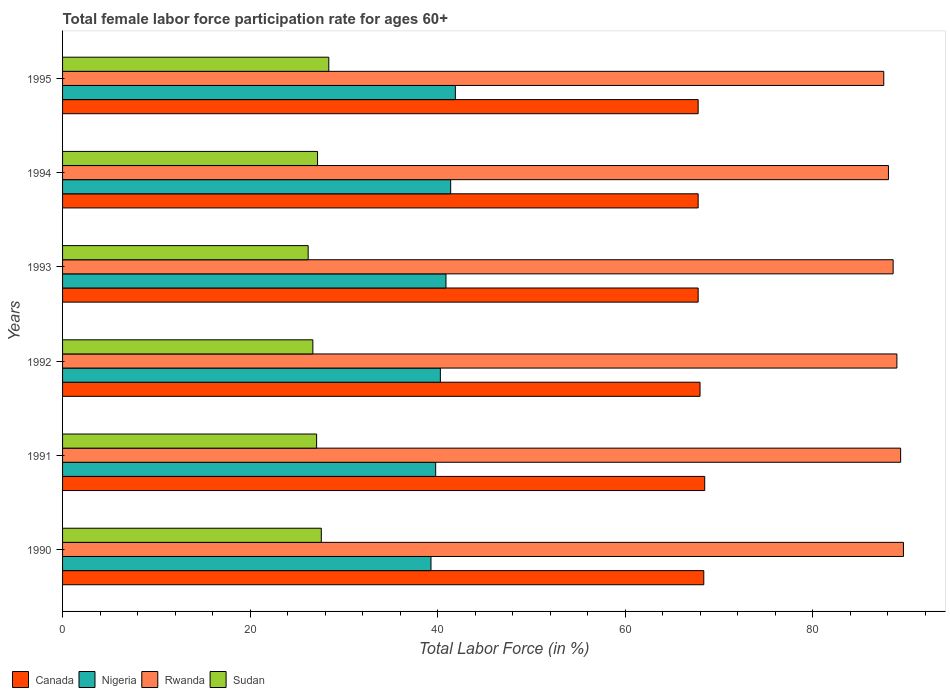How many groups of bars are there?
Offer a terse response. 6. Are the number of bars per tick equal to the number of legend labels?
Your response must be concise. Yes. How many bars are there on the 3rd tick from the top?
Provide a succinct answer. 4. How many bars are there on the 6th tick from the bottom?
Your response must be concise. 4. What is the label of the 2nd group of bars from the top?
Offer a terse response. 1994. In how many cases, is the number of bars for a given year not equal to the number of legend labels?
Give a very brief answer. 0. What is the female labor force participation rate in Canada in 1994?
Provide a short and direct response. 67.8. Across all years, what is the maximum female labor force participation rate in Canada?
Give a very brief answer. 68.5. Across all years, what is the minimum female labor force participation rate in Nigeria?
Offer a very short reply. 39.3. In which year was the female labor force participation rate in Nigeria maximum?
Keep it short and to the point. 1995. What is the total female labor force participation rate in Nigeria in the graph?
Provide a short and direct response. 243.6. What is the difference between the female labor force participation rate in Canada in 1994 and that in 1995?
Give a very brief answer. 0. What is the difference between the female labor force participation rate in Rwanda in 1993 and the female labor force participation rate in Nigeria in 1995?
Ensure brevity in your answer.  46.7. What is the average female labor force participation rate in Canada per year?
Keep it short and to the point. 68.05. In the year 1992, what is the difference between the female labor force participation rate in Canada and female labor force participation rate in Rwanda?
Your answer should be compact. -21. In how many years, is the female labor force participation rate in Nigeria greater than 80 %?
Provide a succinct answer. 0. What is the ratio of the female labor force participation rate in Nigeria in 1991 to that in 1995?
Offer a very short reply. 0.95. Is the female labor force participation rate in Rwanda in 1990 less than that in 1995?
Keep it short and to the point. No. Is the difference between the female labor force participation rate in Canada in 1991 and 1992 greater than the difference between the female labor force participation rate in Rwanda in 1991 and 1992?
Your response must be concise. Yes. What is the difference between the highest and the second highest female labor force participation rate in Nigeria?
Ensure brevity in your answer.  0.5. What is the difference between the highest and the lowest female labor force participation rate in Rwanda?
Ensure brevity in your answer.  2.1. In how many years, is the female labor force participation rate in Canada greater than the average female labor force participation rate in Canada taken over all years?
Keep it short and to the point. 2. Is it the case that in every year, the sum of the female labor force participation rate in Canada and female labor force participation rate in Rwanda is greater than the sum of female labor force participation rate in Sudan and female labor force participation rate in Nigeria?
Make the answer very short. No. What does the 3rd bar from the top in 1995 represents?
Keep it short and to the point. Nigeria. What does the 2nd bar from the bottom in 1991 represents?
Make the answer very short. Nigeria. Is it the case that in every year, the sum of the female labor force participation rate in Nigeria and female labor force participation rate in Canada is greater than the female labor force participation rate in Sudan?
Provide a succinct answer. Yes. Are all the bars in the graph horizontal?
Your response must be concise. Yes. What is the difference between two consecutive major ticks on the X-axis?
Offer a terse response. 20. Are the values on the major ticks of X-axis written in scientific E-notation?
Keep it short and to the point. No. Does the graph contain any zero values?
Your answer should be compact. No. Where does the legend appear in the graph?
Give a very brief answer. Bottom left. What is the title of the graph?
Ensure brevity in your answer.  Total female labor force participation rate for ages 60+. What is the label or title of the X-axis?
Give a very brief answer. Total Labor Force (in %). What is the label or title of the Y-axis?
Keep it short and to the point. Years. What is the Total Labor Force (in %) in Canada in 1990?
Your answer should be very brief. 68.4. What is the Total Labor Force (in %) in Nigeria in 1990?
Your response must be concise. 39.3. What is the Total Labor Force (in %) of Rwanda in 1990?
Your answer should be very brief. 89.7. What is the Total Labor Force (in %) in Sudan in 1990?
Your answer should be compact. 27.6. What is the Total Labor Force (in %) of Canada in 1991?
Offer a very short reply. 68.5. What is the Total Labor Force (in %) of Nigeria in 1991?
Your answer should be very brief. 39.8. What is the Total Labor Force (in %) of Rwanda in 1991?
Provide a succinct answer. 89.4. What is the Total Labor Force (in %) of Sudan in 1991?
Offer a very short reply. 27.1. What is the Total Labor Force (in %) of Canada in 1992?
Offer a terse response. 68. What is the Total Labor Force (in %) in Nigeria in 1992?
Provide a short and direct response. 40.3. What is the Total Labor Force (in %) of Rwanda in 1992?
Provide a succinct answer. 89. What is the Total Labor Force (in %) of Sudan in 1992?
Keep it short and to the point. 26.7. What is the Total Labor Force (in %) of Canada in 1993?
Give a very brief answer. 67.8. What is the Total Labor Force (in %) in Nigeria in 1993?
Make the answer very short. 40.9. What is the Total Labor Force (in %) in Rwanda in 1993?
Your response must be concise. 88.6. What is the Total Labor Force (in %) of Sudan in 1993?
Your response must be concise. 26.2. What is the Total Labor Force (in %) of Canada in 1994?
Your answer should be very brief. 67.8. What is the Total Labor Force (in %) of Nigeria in 1994?
Offer a terse response. 41.4. What is the Total Labor Force (in %) of Rwanda in 1994?
Provide a short and direct response. 88.1. What is the Total Labor Force (in %) in Sudan in 1994?
Give a very brief answer. 27.2. What is the Total Labor Force (in %) in Canada in 1995?
Provide a succinct answer. 67.8. What is the Total Labor Force (in %) of Nigeria in 1995?
Keep it short and to the point. 41.9. What is the Total Labor Force (in %) in Rwanda in 1995?
Ensure brevity in your answer.  87.6. What is the Total Labor Force (in %) of Sudan in 1995?
Ensure brevity in your answer.  28.4. Across all years, what is the maximum Total Labor Force (in %) of Canada?
Make the answer very short. 68.5. Across all years, what is the maximum Total Labor Force (in %) of Nigeria?
Your answer should be compact. 41.9. Across all years, what is the maximum Total Labor Force (in %) of Rwanda?
Make the answer very short. 89.7. Across all years, what is the maximum Total Labor Force (in %) in Sudan?
Your answer should be compact. 28.4. Across all years, what is the minimum Total Labor Force (in %) of Canada?
Offer a terse response. 67.8. Across all years, what is the minimum Total Labor Force (in %) in Nigeria?
Your response must be concise. 39.3. Across all years, what is the minimum Total Labor Force (in %) in Rwanda?
Your response must be concise. 87.6. Across all years, what is the minimum Total Labor Force (in %) in Sudan?
Offer a terse response. 26.2. What is the total Total Labor Force (in %) in Canada in the graph?
Offer a very short reply. 408.3. What is the total Total Labor Force (in %) of Nigeria in the graph?
Offer a very short reply. 243.6. What is the total Total Labor Force (in %) in Rwanda in the graph?
Provide a succinct answer. 532.4. What is the total Total Labor Force (in %) of Sudan in the graph?
Make the answer very short. 163.2. What is the difference between the Total Labor Force (in %) in Canada in 1990 and that in 1991?
Provide a short and direct response. -0.1. What is the difference between the Total Labor Force (in %) of Nigeria in 1990 and that in 1991?
Your answer should be compact. -0.5. What is the difference between the Total Labor Force (in %) in Rwanda in 1990 and that in 1991?
Give a very brief answer. 0.3. What is the difference between the Total Labor Force (in %) in Nigeria in 1990 and that in 1992?
Your answer should be compact. -1. What is the difference between the Total Labor Force (in %) in Rwanda in 1990 and that in 1992?
Keep it short and to the point. 0.7. What is the difference between the Total Labor Force (in %) of Canada in 1990 and that in 1993?
Offer a terse response. 0.6. What is the difference between the Total Labor Force (in %) in Sudan in 1990 and that in 1993?
Make the answer very short. 1.4. What is the difference between the Total Labor Force (in %) in Canada in 1990 and that in 1994?
Provide a short and direct response. 0.6. What is the difference between the Total Labor Force (in %) of Nigeria in 1990 and that in 1994?
Offer a very short reply. -2.1. What is the difference between the Total Labor Force (in %) in Rwanda in 1990 and that in 1994?
Ensure brevity in your answer.  1.6. What is the difference between the Total Labor Force (in %) of Sudan in 1990 and that in 1994?
Offer a very short reply. 0.4. What is the difference between the Total Labor Force (in %) of Canada in 1990 and that in 1995?
Keep it short and to the point. 0.6. What is the difference between the Total Labor Force (in %) in Nigeria in 1990 and that in 1995?
Make the answer very short. -2.6. What is the difference between the Total Labor Force (in %) of Rwanda in 1990 and that in 1995?
Ensure brevity in your answer.  2.1. What is the difference between the Total Labor Force (in %) of Sudan in 1990 and that in 1995?
Give a very brief answer. -0.8. What is the difference between the Total Labor Force (in %) in Canada in 1991 and that in 1992?
Give a very brief answer. 0.5. What is the difference between the Total Labor Force (in %) of Rwanda in 1991 and that in 1992?
Your answer should be very brief. 0.4. What is the difference between the Total Labor Force (in %) of Sudan in 1991 and that in 1992?
Give a very brief answer. 0.4. What is the difference between the Total Labor Force (in %) of Canada in 1991 and that in 1993?
Offer a terse response. 0.7. What is the difference between the Total Labor Force (in %) of Nigeria in 1991 and that in 1993?
Offer a terse response. -1.1. What is the difference between the Total Labor Force (in %) in Sudan in 1991 and that in 1993?
Your answer should be compact. 0.9. What is the difference between the Total Labor Force (in %) of Canada in 1991 and that in 1994?
Ensure brevity in your answer.  0.7. What is the difference between the Total Labor Force (in %) in Rwanda in 1991 and that in 1994?
Make the answer very short. 1.3. What is the difference between the Total Labor Force (in %) in Sudan in 1991 and that in 1994?
Provide a short and direct response. -0.1. What is the difference between the Total Labor Force (in %) of Canada in 1991 and that in 1995?
Your answer should be compact. 0.7. What is the difference between the Total Labor Force (in %) in Sudan in 1991 and that in 1995?
Make the answer very short. -1.3. What is the difference between the Total Labor Force (in %) of Nigeria in 1992 and that in 1993?
Keep it short and to the point. -0.6. What is the difference between the Total Labor Force (in %) of Rwanda in 1992 and that in 1993?
Keep it short and to the point. 0.4. What is the difference between the Total Labor Force (in %) in Sudan in 1992 and that in 1993?
Keep it short and to the point. 0.5. What is the difference between the Total Labor Force (in %) in Canada in 1992 and that in 1994?
Ensure brevity in your answer.  0.2. What is the difference between the Total Labor Force (in %) of Nigeria in 1992 and that in 1994?
Offer a very short reply. -1.1. What is the difference between the Total Labor Force (in %) of Rwanda in 1992 and that in 1994?
Offer a very short reply. 0.9. What is the difference between the Total Labor Force (in %) in Sudan in 1992 and that in 1994?
Make the answer very short. -0.5. What is the difference between the Total Labor Force (in %) of Nigeria in 1992 and that in 1995?
Your answer should be compact. -1.6. What is the difference between the Total Labor Force (in %) in Rwanda in 1992 and that in 1995?
Give a very brief answer. 1.4. What is the difference between the Total Labor Force (in %) in Canada in 1993 and that in 1994?
Your response must be concise. 0. What is the difference between the Total Labor Force (in %) in Nigeria in 1993 and that in 1994?
Provide a succinct answer. -0.5. What is the difference between the Total Labor Force (in %) of Rwanda in 1993 and that in 1994?
Ensure brevity in your answer.  0.5. What is the difference between the Total Labor Force (in %) of Canada in 1993 and that in 1995?
Ensure brevity in your answer.  0. What is the difference between the Total Labor Force (in %) of Nigeria in 1993 and that in 1995?
Your answer should be very brief. -1. What is the difference between the Total Labor Force (in %) in Rwanda in 1993 and that in 1995?
Give a very brief answer. 1. What is the difference between the Total Labor Force (in %) in Sudan in 1993 and that in 1995?
Your answer should be compact. -2.2. What is the difference between the Total Labor Force (in %) in Sudan in 1994 and that in 1995?
Your answer should be compact. -1.2. What is the difference between the Total Labor Force (in %) in Canada in 1990 and the Total Labor Force (in %) in Nigeria in 1991?
Offer a very short reply. 28.6. What is the difference between the Total Labor Force (in %) of Canada in 1990 and the Total Labor Force (in %) of Sudan in 1991?
Your answer should be compact. 41.3. What is the difference between the Total Labor Force (in %) of Nigeria in 1990 and the Total Labor Force (in %) of Rwanda in 1991?
Offer a terse response. -50.1. What is the difference between the Total Labor Force (in %) in Nigeria in 1990 and the Total Labor Force (in %) in Sudan in 1991?
Offer a terse response. 12.2. What is the difference between the Total Labor Force (in %) in Rwanda in 1990 and the Total Labor Force (in %) in Sudan in 1991?
Offer a terse response. 62.6. What is the difference between the Total Labor Force (in %) of Canada in 1990 and the Total Labor Force (in %) of Nigeria in 1992?
Provide a short and direct response. 28.1. What is the difference between the Total Labor Force (in %) of Canada in 1990 and the Total Labor Force (in %) of Rwanda in 1992?
Offer a terse response. -20.6. What is the difference between the Total Labor Force (in %) of Canada in 1990 and the Total Labor Force (in %) of Sudan in 1992?
Offer a terse response. 41.7. What is the difference between the Total Labor Force (in %) in Nigeria in 1990 and the Total Labor Force (in %) in Rwanda in 1992?
Provide a succinct answer. -49.7. What is the difference between the Total Labor Force (in %) in Canada in 1990 and the Total Labor Force (in %) in Nigeria in 1993?
Provide a succinct answer. 27.5. What is the difference between the Total Labor Force (in %) in Canada in 1990 and the Total Labor Force (in %) in Rwanda in 1993?
Offer a terse response. -20.2. What is the difference between the Total Labor Force (in %) in Canada in 1990 and the Total Labor Force (in %) in Sudan in 1993?
Make the answer very short. 42.2. What is the difference between the Total Labor Force (in %) of Nigeria in 1990 and the Total Labor Force (in %) of Rwanda in 1993?
Provide a succinct answer. -49.3. What is the difference between the Total Labor Force (in %) in Nigeria in 1990 and the Total Labor Force (in %) in Sudan in 1993?
Make the answer very short. 13.1. What is the difference between the Total Labor Force (in %) of Rwanda in 1990 and the Total Labor Force (in %) of Sudan in 1993?
Provide a short and direct response. 63.5. What is the difference between the Total Labor Force (in %) in Canada in 1990 and the Total Labor Force (in %) in Nigeria in 1994?
Provide a succinct answer. 27. What is the difference between the Total Labor Force (in %) of Canada in 1990 and the Total Labor Force (in %) of Rwanda in 1994?
Offer a terse response. -19.7. What is the difference between the Total Labor Force (in %) in Canada in 1990 and the Total Labor Force (in %) in Sudan in 1994?
Offer a terse response. 41.2. What is the difference between the Total Labor Force (in %) in Nigeria in 1990 and the Total Labor Force (in %) in Rwanda in 1994?
Make the answer very short. -48.8. What is the difference between the Total Labor Force (in %) of Rwanda in 1990 and the Total Labor Force (in %) of Sudan in 1994?
Provide a succinct answer. 62.5. What is the difference between the Total Labor Force (in %) in Canada in 1990 and the Total Labor Force (in %) in Rwanda in 1995?
Offer a very short reply. -19.2. What is the difference between the Total Labor Force (in %) in Nigeria in 1990 and the Total Labor Force (in %) in Rwanda in 1995?
Your answer should be very brief. -48.3. What is the difference between the Total Labor Force (in %) of Rwanda in 1990 and the Total Labor Force (in %) of Sudan in 1995?
Provide a short and direct response. 61.3. What is the difference between the Total Labor Force (in %) in Canada in 1991 and the Total Labor Force (in %) in Nigeria in 1992?
Ensure brevity in your answer.  28.2. What is the difference between the Total Labor Force (in %) in Canada in 1991 and the Total Labor Force (in %) in Rwanda in 1992?
Give a very brief answer. -20.5. What is the difference between the Total Labor Force (in %) of Canada in 1991 and the Total Labor Force (in %) of Sudan in 1992?
Your response must be concise. 41.8. What is the difference between the Total Labor Force (in %) in Nigeria in 1991 and the Total Labor Force (in %) in Rwanda in 1992?
Your answer should be compact. -49.2. What is the difference between the Total Labor Force (in %) of Nigeria in 1991 and the Total Labor Force (in %) of Sudan in 1992?
Keep it short and to the point. 13.1. What is the difference between the Total Labor Force (in %) in Rwanda in 1991 and the Total Labor Force (in %) in Sudan in 1992?
Your response must be concise. 62.7. What is the difference between the Total Labor Force (in %) in Canada in 1991 and the Total Labor Force (in %) in Nigeria in 1993?
Your answer should be compact. 27.6. What is the difference between the Total Labor Force (in %) in Canada in 1991 and the Total Labor Force (in %) in Rwanda in 1993?
Make the answer very short. -20.1. What is the difference between the Total Labor Force (in %) of Canada in 1991 and the Total Labor Force (in %) of Sudan in 1993?
Offer a terse response. 42.3. What is the difference between the Total Labor Force (in %) of Nigeria in 1991 and the Total Labor Force (in %) of Rwanda in 1993?
Your answer should be compact. -48.8. What is the difference between the Total Labor Force (in %) of Nigeria in 1991 and the Total Labor Force (in %) of Sudan in 1993?
Your answer should be very brief. 13.6. What is the difference between the Total Labor Force (in %) in Rwanda in 1991 and the Total Labor Force (in %) in Sudan in 1993?
Ensure brevity in your answer.  63.2. What is the difference between the Total Labor Force (in %) in Canada in 1991 and the Total Labor Force (in %) in Nigeria in 1994?
Make the answer very short. 27.1. What is the difference between the Total Labor Force (in %) in Canada in 1991 and the Total Labor Force (in %) in Rwanda in 1994?
Your answer should be very brief. -19.6. What is the difference between the Total Labor Force (in %) of Canada in 1991 and the Total Labor Force (in %) of Sudan in 1994?
Your response must be concise. 41.3. What is the difference between the Total Labor Force (in %) in Nigeria in 1991 and the Total Labor Force (in %) in Rwanda in 1994?
Your answer should be compact. -48.3. What is the difference between the Total Labor Force (in %) in Rwanda in 1991 and the Total Labor Force (in %) in Sudan in 1994?
Provide a short and direct response. 62.2. What is the difference between the Total Labor Force (in %) of Canada in 1991 and the Total Labor Force (in %) of Nigeria in 1995?
Offer a terse response. 26.6. What is the difference between the Total Labor Force (in %) of Canada in 1991 and the Total Labor Force (in %) of Rwanda in 1995?
Give a very brief answer. -19.1. What is the difference between the Total Labor Force (in %) in Canada in 1991 and the Total Labor Force (in %) in Sudan in 1995?
Provide a succinct answer. 40.1. What is the difference between the Total Labor Force (in %) of Nigeria in 1991 and the Total Labor Force (in %) of Rwanda in 1995?
Offer a very short reply. -47.8. What is the difference between the Total Labor Force (in %) in Nigeria in 1991 and the Total Labor Force (in %) in Sudan in 1995?
Your answer should be very brief. 11.4. What is the difference between the Total Labor Force (in %) in Rwanda in 1991 and the Total Labor Force (in %) in Sudan in 1995?
Provide a succinct answer. 61. What is the difference between the Total Labor Force (in %) of Canada in 1992 and the Total Labor Force (in %) of Nigeria in 1993?
Your answer should be very brief. 27.1. What is the difference between the Total Labor Force (in %) of Canada in 1992 and the Total Labor Force (in %) of Rwanda in 1993?
Offer a very short reply. -20.6. What is the difference between the Total Labor Force (in %) of Canada in 1992 and the Total Labor Force (in %) of Sudan in 1993?
Ensure brevity in your answer.  41.8. What is the difference between the Total Labor Force (in %) in Nigeria in 1992 and the Total Labor Force (in %) in Rwanda in 1993?
Offer a very short reply. -48.3. What is the difference between the Total Labor Force (in %) in Nigeria in 1992 and the Total Labor Force (in %) in Sudan in 1993?
Give a very brief answer. 14.1. What is the difference between the Total Labor Force (in %) of Rwanda in 1992 and the Total Labor Force (in %) of Sudan in 1993?
Provide a short and direct response. 62.8. What is the difference between the Total Labor Force (in %) in Canada in 1992 and the Total Labor Force (in %) in Nigeria in 1994?
Keep it short and to the point. 26.6. What is the difference between the Total Labor Force (in %) in Canada in 1992 and the Total Labor Force (in %) in Rwanda in 1994?
Provide a short and direct response. -20.1. What is the difference between the Total Labor Force (in %) of Canada in 1992 and the Total Labor Force (in %) of Sudan in 1994?
Your answer should be very brief. 40.8. What is the difference between the Total Labor Force (in %) of Nigeria in 1992 and the Total Labor Force (in %) of Rwanda in 1994?
Offer a very short reply. -47.8. What is the difference between the Total Labor Force (in %) in Rwanda in 1992 and the Total Labor Force (in %) in Sudan in 1994?
Your answer should be very brief. 61.8. What is the difference between the Total Labor Force (in %) in Canada in 1992 and the Total Labor Force (in %) in Nigeria in 1995?
Offer a terse response. 26.1. What is the difference between the Total Labor Force (in %) in Canada in 1992 and the Total Labor Force (in %) in Rwanda in 1995?
Provide a short and direct response. -19.6. What is the difference between the Total Labor Force (in %) of Canada in 1992 and the Total Labor Force (in %) of Sudan in 1995?
Make the answer very short. 39.6. What is the difference between the Total Labor Force (in %) of Nigeria in 1992 and the Total Labor Force (in %) of Rwanda in 1995?
Offer a very short reply. -47.3. What is the difference between the Total Labor Force (in %) of Nigeria in 1992 and the Total Labor Force (in %) of Sudan in 1995?
Provide a short and direct response. 11.9. What is the difference between the Total Labor Force (in %) of Rwanda in 1992 and the Total Labor Force (in %) of Sudan in 1995?
Your answer should be compact. 60.6. What is the difference between the Total Labor Force (in %) of Canada in 1993 and the Total Labor Force (in %) of Nigeria in 1994?
Give a very brief answer. 26.4. What is the difference between the Total Labor Force (in %) of Canada in 1993 and the Total Labor Force (in %) of Rwanda in 1994?
Ensure brevity in your answer.  -20.3. What is the difference between the Total Labor Force (in %) of Canada in 1993 and the Total Labor Force (in %) of Sudan in 1994?
Your answer should be compact. 40.6. What is the difference between the Total Labor Force (in %) in Nigeria in 1993 and the Total Labor Force (in %) in Rwanda in 1994?
Offer a very short reply. -47.2. What is the difference between the Total Labor Force (in %) in Nigeria in 1993 and the Total Labor Force (in %) in Sudan in 1994?
Your response must be concise. 13.7. What is the difference between the Total Labor Force (in %) in Rwanda in 1993 and the Total Labor Force (in %) in Sudan in 1994?
Give a very brief answer. 61.4. What is the difference between the Total Labor Force (in %) in Canada in 1993 and the Total Labor Force (in %) in Nigeria in 1995?
Give a very brief answer. 25.9. What is the difference between the Total Labor Force (in %) in Canada in 1993 and the Total Labor Force (in %) in Rwanda in 1995?
Ensure brevity in your answer.  -19.8. What is the difference between the Total Labor Force (in %) in Canada in 1993 and the Total Labor Force (in %) in Sudan in 1995?
Give a very brief answer. 39.4. What is the difference between the Total Labor Force (in %) of Nigeria in 1993 and the Total Labor Force (in %) of Rwanda in 1995?
Make the answer very short. -46.7. What is the difference between the Total Labor Force (in %) of Nigeria in 1993 and the Total Labor Force (in %) of Sudan in 1995?
Make the answer very short. 12.5. What is the difference between the Total Labor Force (in %) in Rwanda in 1993 and the Total Labor Force (in %) in Sudan in 1995?
Offer a terse response. 60.2. What is the difference between the Total Labor Force (in %) of Canada in 1994 and the Total Labor Force (in %) of Nigeria in 1995?
Make the answer very short. 25.9. What is the difference between the Total Labor Force (in %) of Canada in 1994 and the Total Labor Force (in %) of Rwanda in 1995?
Offer a terse response. -19.8. What is the difference between the Total Labor Force (in %) in Canada in 1994 and the Total Labor Force (in %) in Sudan in 1995?
Give a very brief answer. 39.4. What is the difference between the Total Labor Force (in %) in Nigeria in 1994 and the Total Labor Force (in %) in Rwanda in 1995?
Provide a short and direct response. -46.2. What is the difference between the Total Labor Force (in %) of Rwanda in 1994 and the Total Labor Force (in %) of Sudan in 1995?
Provide a short and direct response. 59.7. What is the average Total Labor Force (in %) in Canada per year?
Provide a short and direct response. 68.05. What is the average Total Labor Force (in %) of Nigeria per year?
Keep it short and to the point. 40.6. What is the average Total Labor Force (in %) in Rwanda per year?
Ensure brevity in your answer.  88.73. What is the average Total Labor Force (in %) in Sudan per year?
Give a very brief answer. 27.2. In the year 1990, what is the difference between the Total Labor Force (in %) in Canada and Total Labor Force (in %) in Nigeria?
Offer a very short reply. 29.1. In the year 1990, what is the difference between the Total Labor Force (in %) in Canada and Total Labor Force (in %) in Rwanda?
Provide a succinct answer. -21.3. In the year 1990, what is the difference between the Total Labor Force (in %) of Canada and Total Labor Force (in %) of Sudan?
Provide a succinct answer. 40.8. In the year 1990, what is the difference between the Total Labor Force (in %) in Nigeria and Total Labor Force (in %) in Rwanda?
Keep it short and to the point. -50.4. In the year 1990, what is the difference between the Total Labor Force (in %) of Nigeria and Total Labor Force (in %) of Sudan?
Keep it short and to the point. 11.7. In the year 1990, what is the difference between the Total Labor Force (in %) of Rwanda and Total Labor Force (in %) of Sudan?
Ensure brevity in your answer.  62.1. In the year 1991, what is the difference between the Total Labor Force (in %) in Canada and Total Labor Force (in %) in Nigeria?
Give a very brief answer. 28.7. In the year 1991, what is the difference between the Total Labor Force (in %) of Canada and Total Labor Force (in %) of Rwanda?
Ensure brevity in your answer.  -20.9. In the year 1991, what is the difference between the Total Labor Force (in %) in Canada and Total Labor Force (in %) in Sudan?
Your answer should be compact. 41.4. In the year 1991, what is the difference between the Total Labor Force (in %) of Nigeria and Total Labor Force (in %) of Rwanda?
Offer a very short reply. -49.6. In the year 1991, what is the difference between the Total Labor Force (in %) in Nigeria and Total Labor Force (in %) in Sudan?
Keep it short and to the point. 12.7. In the year 1991, what is the difference between the Total Labor Force (in %) in Rwanda and Total Labor Force (in %) in Sudan?
Give a very brief answer. 62.3. In the year 1992, what is the difference between the Total Labor Force (in %) in Canada and Total Labor Force (in %) in Nigeria?
Ensure brevity in your answer.  27.7. In the year 1992, what is the difference between the Total Labor Force (in %) in Canada and Total Labor Force (in %) in Rwanda?
Provide a succinct answer. -21. In the year 1992, what is the difference between the Total Labor Force (in %) of Canada and Total Labor Force (in %) of Sudan?
Your answer should be compact. 41.3. In the year 1992, what is the difference between the Total Labor Force (in %) of Nigeria and Total Labor Force (in %) of Rwanda?
Ensure brevity in your answer.  -48.7. In the year 1992, what is the difference between the Total Labor Force (in %) of Rwanda and Total Labor Force (in %) of Sudan?
Give a very brief answer. 62.3. In the year 1993, what is the difference between the Total Labor Force (in %) in Canada and Total Labor Force (in %) in Nigeria?
Ensure brevity in your answer.  26.9. In the year 1993, what is the difference between the Total Labor Force (in %) of Canada and Total Labor Force (in %) of Rwanda?
Give a very brief answer. -20.8. In the year 1993, what is the difference between the Total Labor Force (in %) of Canada and Total Labor Force (in %) of Sudan?
Provide a succinct answer. 41.6. In the year 1993, what is the difference between the Total Labor Force (in %) of Nigeria and Total Labor Force (in %) of Rwanda?
Keep it short and to the point. -47.7. In the year 1993, what is the difference between the Total Labor Force (in %) of Rwanda and Total Labor Force (in %) of Sudan?
Your answer should be very brief. 62.4. In the year 1994, what is the difference between the Total Labor Force (in %) in Canada and Total Labor Force (in %) in Nigeria?
Ensure brevity in your answer.  26.4. In the year 1994, what is the difference between the Total Labor Force (in %) of Canada and Total Labor Force (in %) of Rwanda?
Provide a succinct answer. -20.3. In the year 1994, what is the difference between the Total Labor Force (in %) in Canada and Total Labor Force (in %) in Sudan?
Your answer should be compact. 40.6. In the year 1994, what is the difference between the Total Labor Force (in %) in Nigeria and Total Labor Force (in %) in Rwanda?
Your response must be concise. -46.7. In the year 1994, what is the difference between the Total Labor Force (in %) of Nigeria and Total Labor Force (in %) of Sudan?
Provide a succinct answer. 14.2. In the year 1994, what is the difference between the Total Labor Force (in %) of Rwanda and Total Labor Force (in %) of Sudan?
Your answer should be very brief. 60.9. In the year 1995, what is the difference between the Total Labor Force (in %) of Canada and Total Labor Force (in %) of Nigeria?
Ensure brevity in your answer.  25.9. In the year 1995, what is the difference between the Total Labor Force (in %) of Canada and Total Labor Force (in %) of Rwanda?
Offer a terse response. -19.8. In the year 1995, what is the difference between the Total Labor Force (in %) of Canada and Total Labor Force (in %) of Sudan?
Keep it short and to the point. 39.4. In the year 1995, what is the difference between the Total Labor Force (in %) of Nigeria and Total Labor Force (in %) of Rwanda?
Offer a very short reply. -45.7. In the year 1995, what is the difference between the Total Labor Force (in %) of Nigeria and Total Labor Force (in %) of Sudan?
Provide a succinct answer. 13.5. In the year 1995, what is the difference between the Total Labor Force (in %) in Rwanda and Total Labor Force (in %) in Sudan?
Ensure brevity in your answer.  59.2. What is the ratio of the Total Labor Force (in %) of Canada in 1990 to that in 1991?
Keep it short and to the point. 1. What is the ratio of the Total Labor Force (in %) of Nigeria in 1990 to that in 1991?
Keep it short and to the point. 0.99. What is the ratio of the Total Labor Force (in %) of Sudan in 1990 to that in 1991?
Offer a very short reply. 1.02. What is the ratio of the Total Labor Force (in %) in Canada in 1990 to that in 1992?
Provide a short and direct response. 1.01. What is the ratio of the Total Labor Force (in %) of Nigeria in 1990 to that in 1992?
Keep it short and to the point. 0.98. What is the ratio of the Total Labor Force (in %) in Rwanda in 1990 to that in 1992?
Keep it short and to the point. 1.01. What is the ratio of the Total Labor Force (in %) in Sudan in 1990 to that in 1992?
Ensure brevity in your answer.  1.03. What is the ratio of the Total Labor Force (in %) in Canada in 1990 to that in 1993?
Your response must be concise. 1.01. What is the ratio of the Total Labor Force (in %) in Nigeria in 1990 to that in 1993?
Keep it short and to the point. 0.96. What is the ratio of the Total Labor Force (in %) in Rwanda in 1990 to that in 1993?
Provide a succinct answer. 1.01. What is the ratio of the Total Labor Force (in %) in Sudan in 1990 to that in 1993?
Offer a terse response. 1.05. What is the ratio of the Total Labor Force (in %) of Canada in 1990 to that in 1994?
Provide a succinct answer. 1.01. What is the ratio of the Total Labor Force (in %) in Nigeria in 1990 to that in 1994?
Your answer should be compact. 0.95. What is the ratio of the Total Labor Force (in %) of Rwanda in 1990 to that in 1994?
Your answer should be compact. 1.02. What is the ratio of the Total Labor Force (in %) in Sudan in 1990 to that in 1994?
Make the answer very short. 1.01. What is the ratio of the Total Labor Force (in %) of Canada in 1990 to that in 1995?
Your response must be concise. 1.01. What is the ratio of the Total Labor Force (in %) in Nigeria in 1990 to that in 1995?
Give a very brief answer. 0.94. What is the ratio of the Total Labor Force (in %) of Rwanda in 1990 to that in 1995?
Your response must be concise. 1.02. What is the ratio of the Total Labor Force (in %) of Sudan in 1990 to that in 1995?
Make the answer very short. 0.97. What is the ratio of the Total Labor Force (in %) of Canada in 1991 to that in 1992?
Your answer should be compact. 1.01. What is the ratio of the Total Labor Force (in %) of Nigeria in 1991 to that in 1992?
Offer a very short reply. 0.99. What is the ratio of the Total Labor Force (in %) of Sudan in 1991 to that in 1992?
Make the answer very short. 1.01. What is the ratio of the Total Labor Force (in %) of Canada in 1991 to that in 1993?
Offer a very short reply. 1.01. What is the ratio of the Total Labor Force (in %) of Nigeria in 1991 to that in 1993?
Offer a very short reply. 0.97. What is the ratio of the Total Labor Force (in %) of Sudan in 1991 to that in 1993?
Offer a terse response. 1.03. What is the ratio of the Total Labor Force (in %) in Canada in 1991 to that in 1994?
Make the answer very short. 1.01. What is the ratio of the Total Labor Force (in %) in Nigeria in 1991 to that in 1994?
Give a very brief answer. 0.96. What is the ratio of the Total Labor Force (in %) of Rwanda in 1991 to that in 1994?
Offer a terse response. 1.01. What is the ratio of the Total Labor Force (in %) in Canada in 1991 to that in 1995?
Offer a terse response. 1.01. What is the ratio of the Total Labor Force (in %) in Nigeria in 1991 to that in 1995?
Your answer should be compact. 0.95. What is the ratio of the Total Labor Force (in %) of Rwanda in 1991 to that in 1995?
Keep it short and to the point. 1.02. What is the ratio of the Total Labor Force (in %) of Sudan in 1991 to that in 1995?
Keep it short and to the point. 0.95. What is the ratio of the Total Labor Force (in %) of Sudan in 1992 to that in 1993?
Give a very brief answer. 1.02. What is the ratio of the Total Labor Force (in %) in Nigeria in 1992 to that in 1994?
Offer a very short reply. 0.97. What is the ratio of the Total Labor Force (in %) of Rwanda in 1992 to that in 1994?
Make the answer very short. 1.01. What is the ratio of the Total Labor Force (in %) in Sudan in 1992 to that in 1994?
Your response must be concise. 0.98. What is the ratio of the Total Labor Force (in %) of Canada in 1992 to that in 1995?
Ensure brevity in your answer.  1. What is the ratio of the Total Labor Force (in %) in Nigeria in 1992 to that in 1995?
Provide a short and direct response. 0.96. What is the ratio of the Total Labor Force (in %) in Rwanda in 1992 to that in 1995?
Your response must be concise. 1.02. What is the ratio of the Total Labor Force (in %) of Sudan in 1992 to that in 1995?
Offer a terse response. 0.94. What is the ratio of the Total Labor Force (in %) in Canada in 1993 to that in 1994?
Your answer should be compact. 1. What is the ratio of the Total Labor Force (in %) of Nigeria in 1993 to that in 1994?
Make the answer very short. 0.99. What is the ratio of the Total Labor Force (in %) in Rwanda in 1993 to that in 1994?
Provide a succinct answer. 1.01. What is the ratio of the Total Labor Force (in %) in Sudan in 1993 to that in 1994?
Offer a terse response. 0.96. What is the ratio of the Total Labor Force (in %) of Canada in 1993 to that in 1995?
Offer a terse response. 1. What is the ratio of the Total Labor Force (in %) of Nigeria in 1993 to that in 1995?
Your answer should be very brief. 0.98. What is the ratio of the Total Labor Force (in %) in Rwanda in 1993 to that in 1995?
Your response must be concise. 1.01. What is the ratio of the Total Labor Force (in %) of Sudan in 1993 to that in 1995?
Your answer should be compact. 0.92. What is the ratio of the Total Labor Force (in %) in Canada in 1994 to that in 1995?
Your answer should be compact. 1. What is the ratio of the Total Labor Force (in %) of Nigeria in 1994 to that in 1995?
Offer a very short reply. 0.99. What is the ratio of the Total Labor Force (in %) of Rwanda in 1994 to that in 1995?
Offer a very short reply. 1.01. What is the ratio of the Total Labor Force (in %) in Sudan in 1994 to that in 1995?
Offer a terse response. 0.96. What is the difference between the highest and the second highest Total Labor Force (in %) of Nigeria?
Your response must be concise. 0.5. What is the difference between the highest and the second highest Total Labor Force (in %) in Rwanda?
Make the answer very short. 0.3. What is the difference between the highest and the second highest Total Labor Force (in %) of Sudan?
Provide a succinct answer. 0.8. What is the difference between the highest and the lowest Total Labor Force (in %) in Nigeria?
Keep it short and to the point. 2.6. 